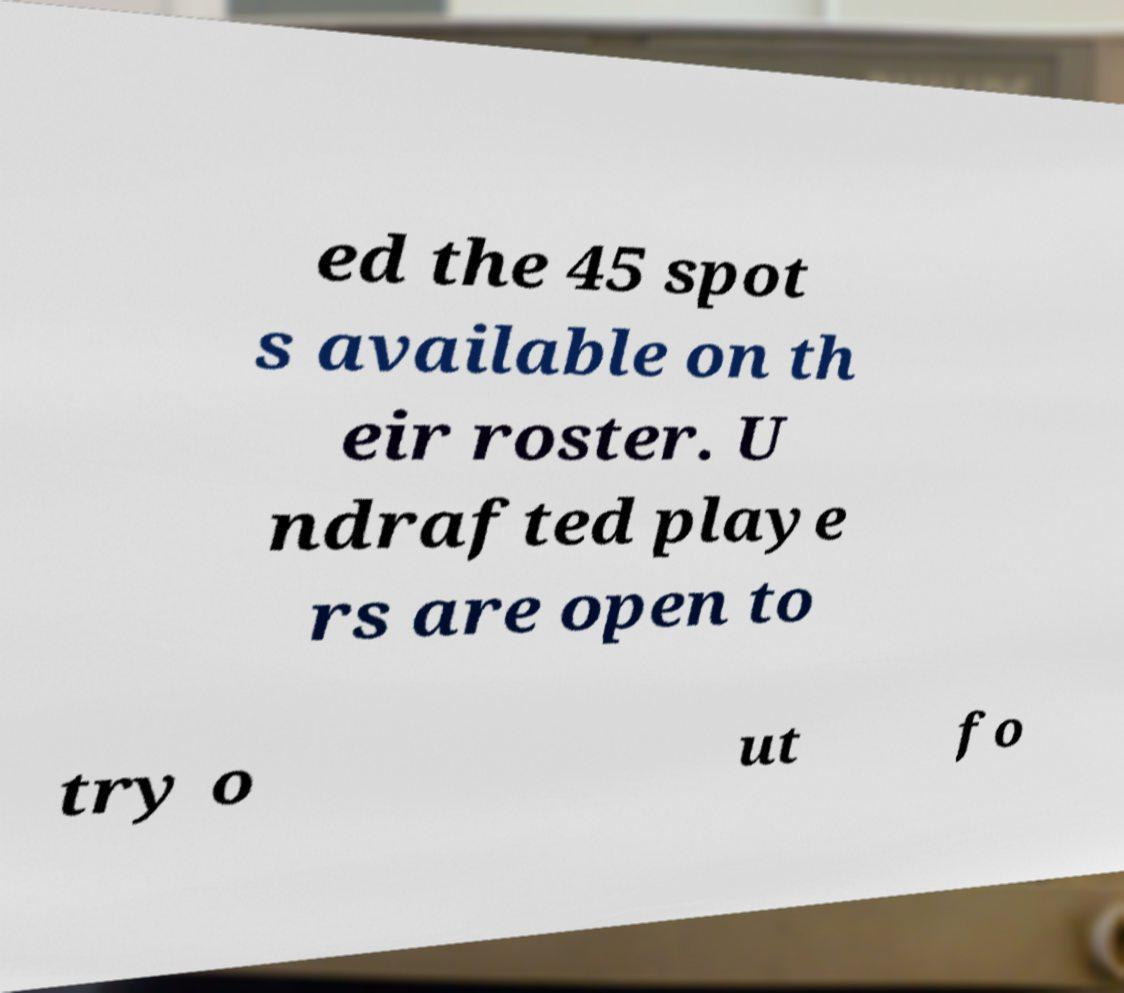Can you accurately transcribe the text from the provided image for me? ed the 45 spot s available on th eir roster. U ndrafted playe rs are open to try o ut fo 